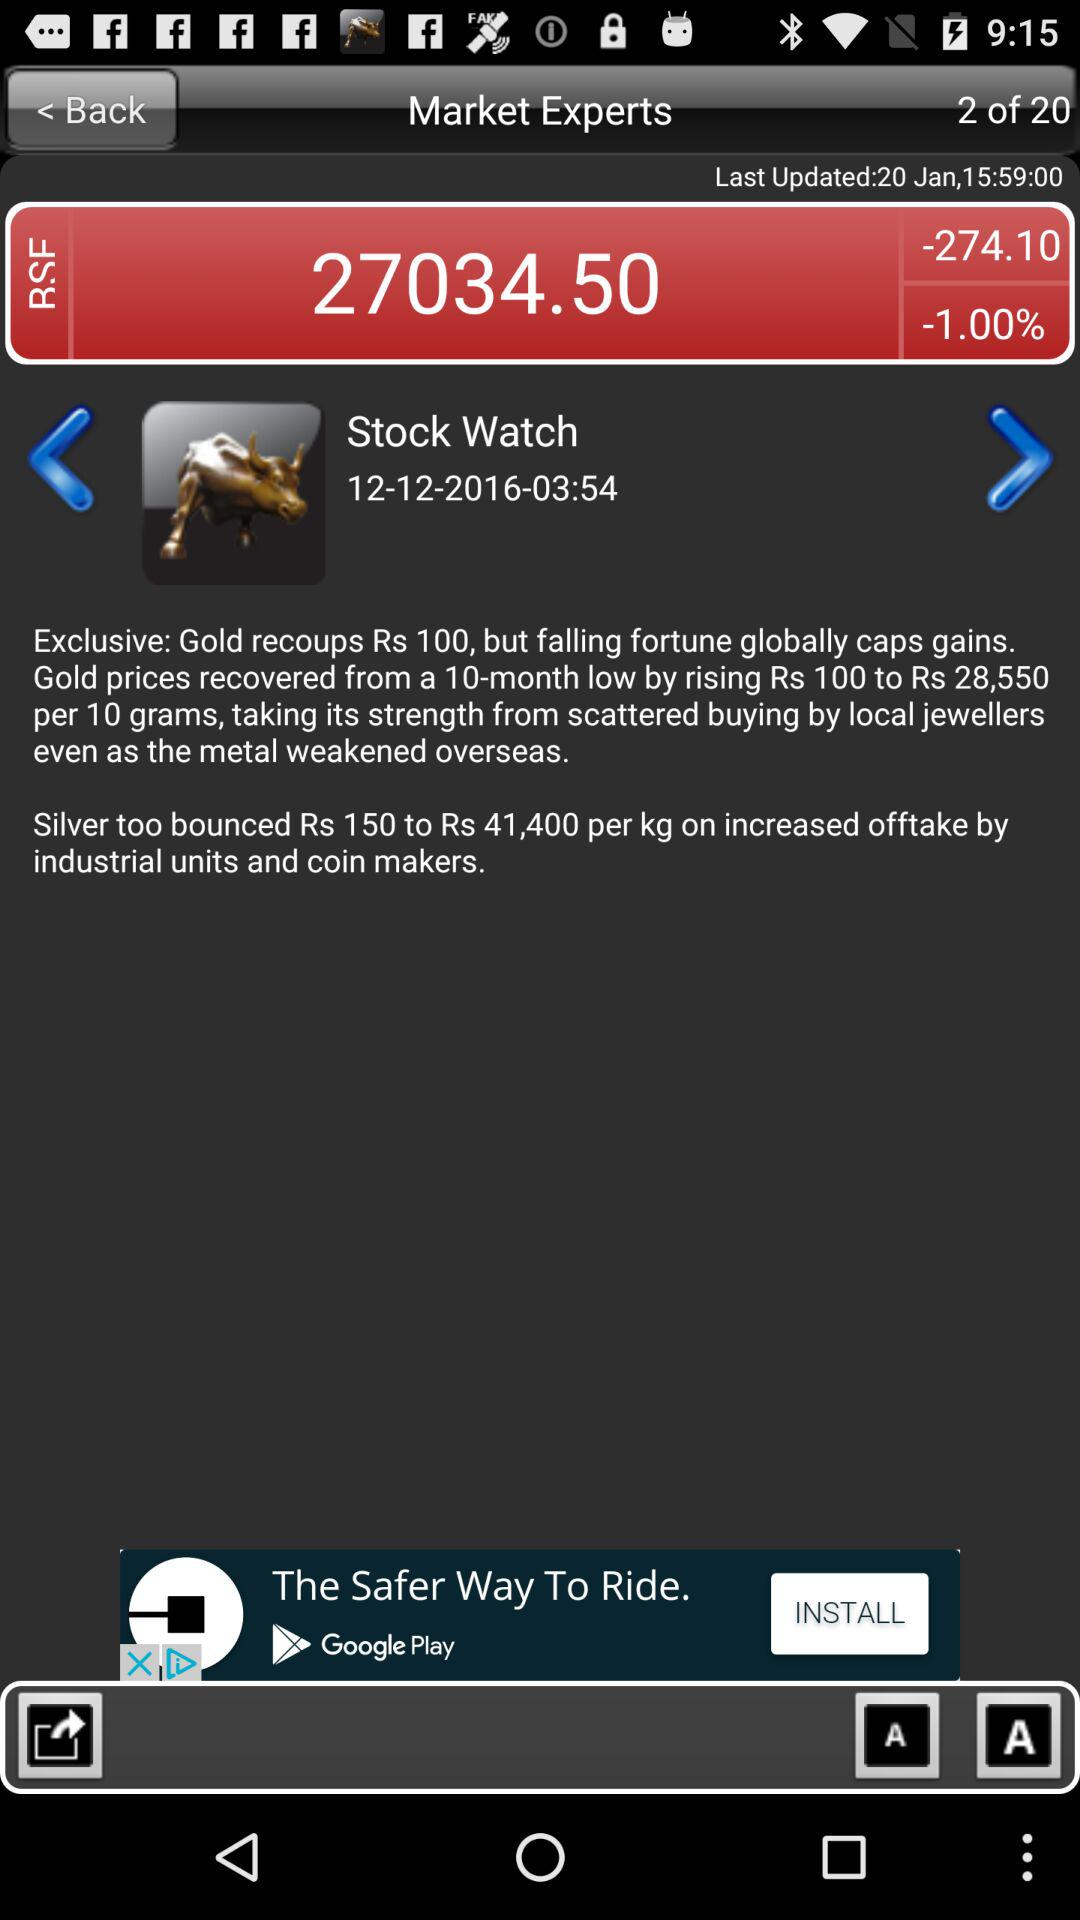What is the percentage change in the stock on the BSE? The percentage change in the stock on the BSE is -1.00. 